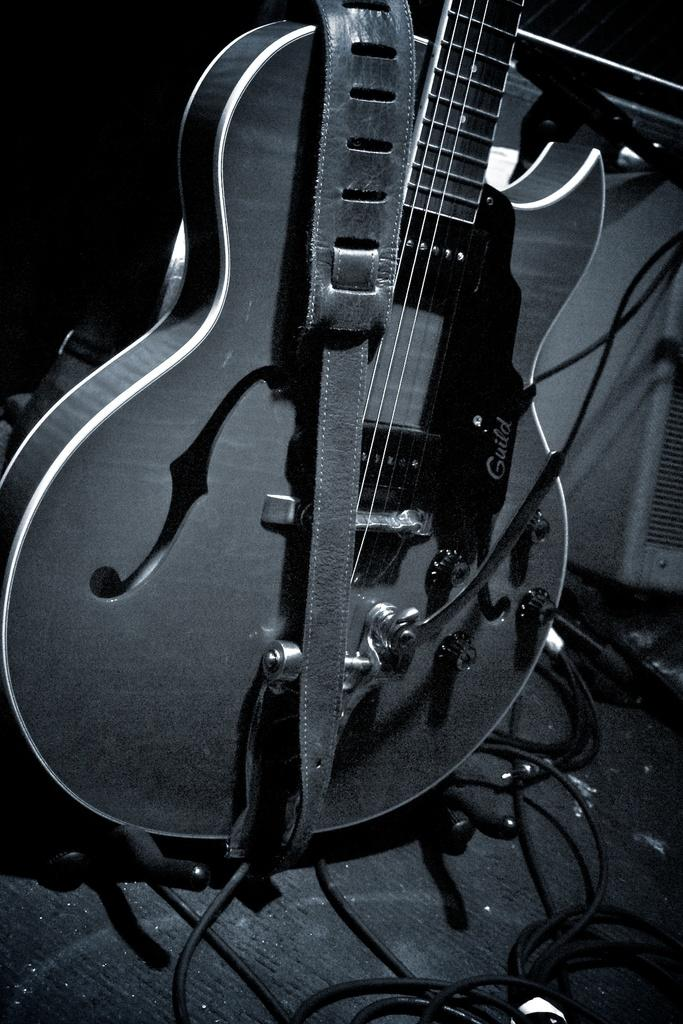What musical instrument is present in the image? There is a guitar in the image. What feature is attached to the guitar? The guitar has a strap. What can be seen in the foreground of the image? There are cables in the foreground of the image. What is located on the right side of the image? There is another object on the right side of the image. What type of army is depicted in the image? There is no army present in the image; it features a guitar with a strap and cables in the foreground. How does the guitar change the mind of the viewer in the image? The image does not depict any mind-changing effects of the guitar; it simply shows the guitar with a strap and cables in the foreground. 